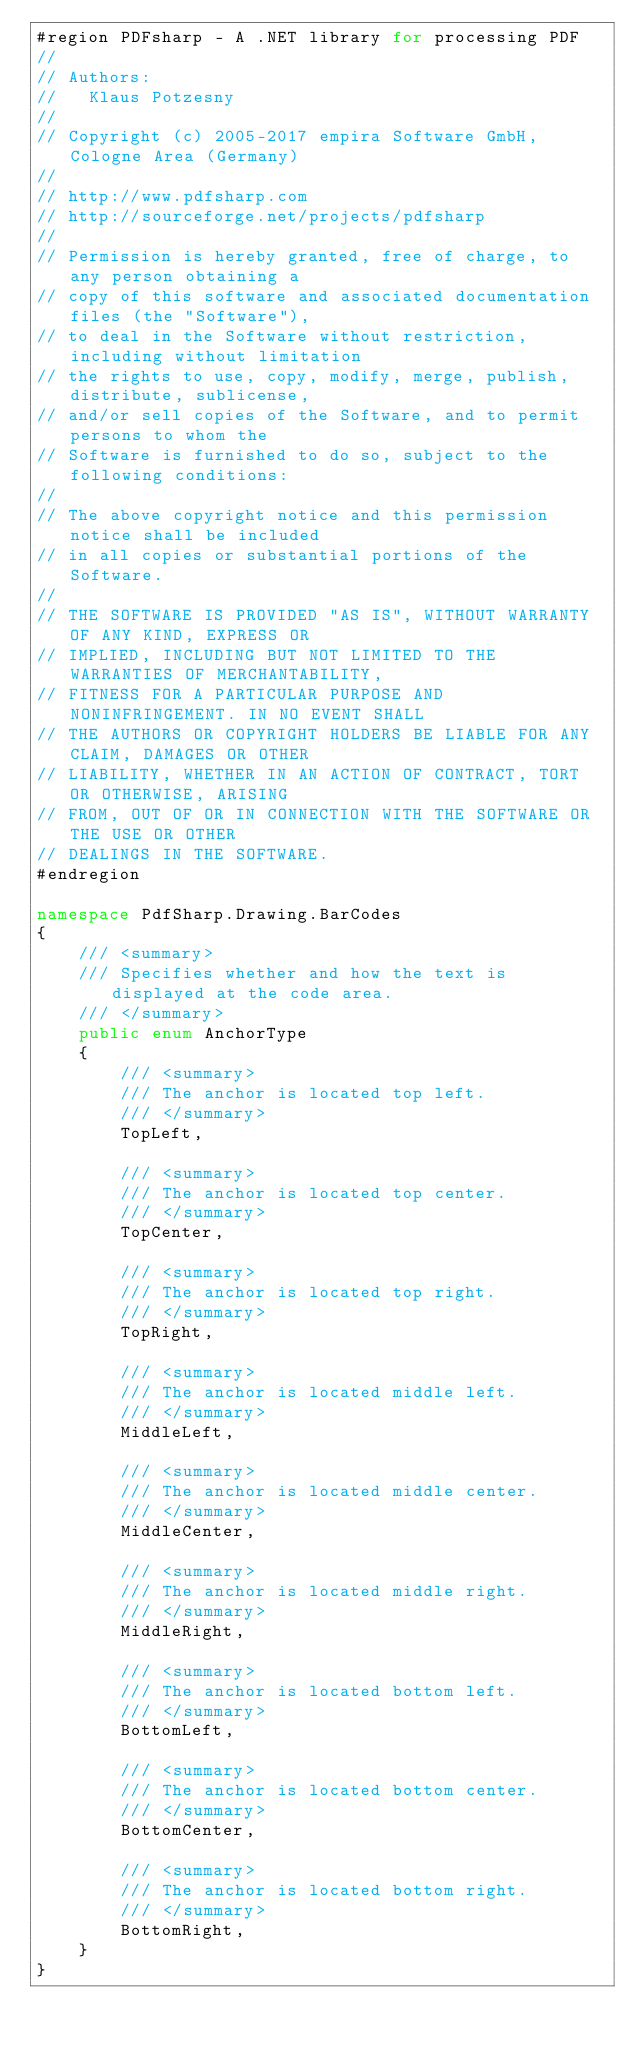<code> <loc_0><loc_0><loc_500><loc_500><_C#_>#region PDFsharp - A .NET library for processing PDF
//
// Authors:
//   Klaus Potzesny
//
// Copyright (c) 2005-2017 empira Software GmbH, Cologne Area (Germany)
//
// http://www.pdfsharp.com
// http://sourceforge.net/projects/pdfsharp
//
// Permission is hereby granted, free of charge, to any person obtaining a
// copy of this software and associated documentation files (the "Software"),
// to deal in the Software without restriction, including without limitation
// the rights to use, copy, modify, merge, publish, distribute, sublicense,
// and/or sell copies of the Software, and to permit persons to whom the
// Software is furnished to do so, subject to the following conditions:
//
// The above copyright notice and this permission notice shall be included
// in all copies or substantial portions of the Software.
//
// THE SOFTWARE IS PROVIDED "AS IS", WITHOUT WARRANTY OF ANY KIND, EXPRESS OR
// IMPLIED, INCLUDING BUT NOT LIMITED TO THE WARRANTIES OF MERCHANTABILITY,
// FITNESS FOR A PARTICULAR PURPOSE AND NONINFRINGEMENT. IN NO EVENT SHALL
// THE AUTHORS OR COPYRIGHT HOLDERS BE LIABLE FOR ANY CLAIM, DAMAGES OR OTHER
// LIABILITY, WHETHER IN AN ACTION OF CONTRACT, TORT OR OTHERWISE, ARISING
// FROM, OUT OF OR IN CONNECTION WITH THE SOFTWARE OR THE USE OR OTHER 
// DEALINGS IN THE SOFTWARE.
#endregion

namespace PdfSharp.Drawing.BarCodes
{
    /// <summary>
    /// Specifies whether and how the text is displayed at the code area.
    /// </summary>
    public enum AnchorType
    {
        /// <summary>
        /// The anchor is located top left.
        /// </summary>
        TopLeft,

        /// <summary>
        /// The anchor is located top center.
        /// </summary>
        TopCenter,

        /// <summary>
        /// The anchor is located top right.
        /// </summary>
        TopRight,

        /// <summary>
        /// The anchor is located middle left.
        /// </summary>
        MiddleLeft,

        /// <summary>
        /// The anchor is located middle center.
        /// </summary>
        MiddleCenter,

        /// <summary>
        /// The anchor is located middle right.
        /// </summary>
        MiddleRight,

        /// <summary>
        /// The anchor is located bottom left.
        /// </summary>
        BottomLeft,

        /// <summary>
        /// The anchor is located bottom center.
        /// </summary>
        BottomCenter,

        /// <summary>
        /// The anchor is located bottom right.
        /// </summary>
        BottomRight,
    }
}
</code> 